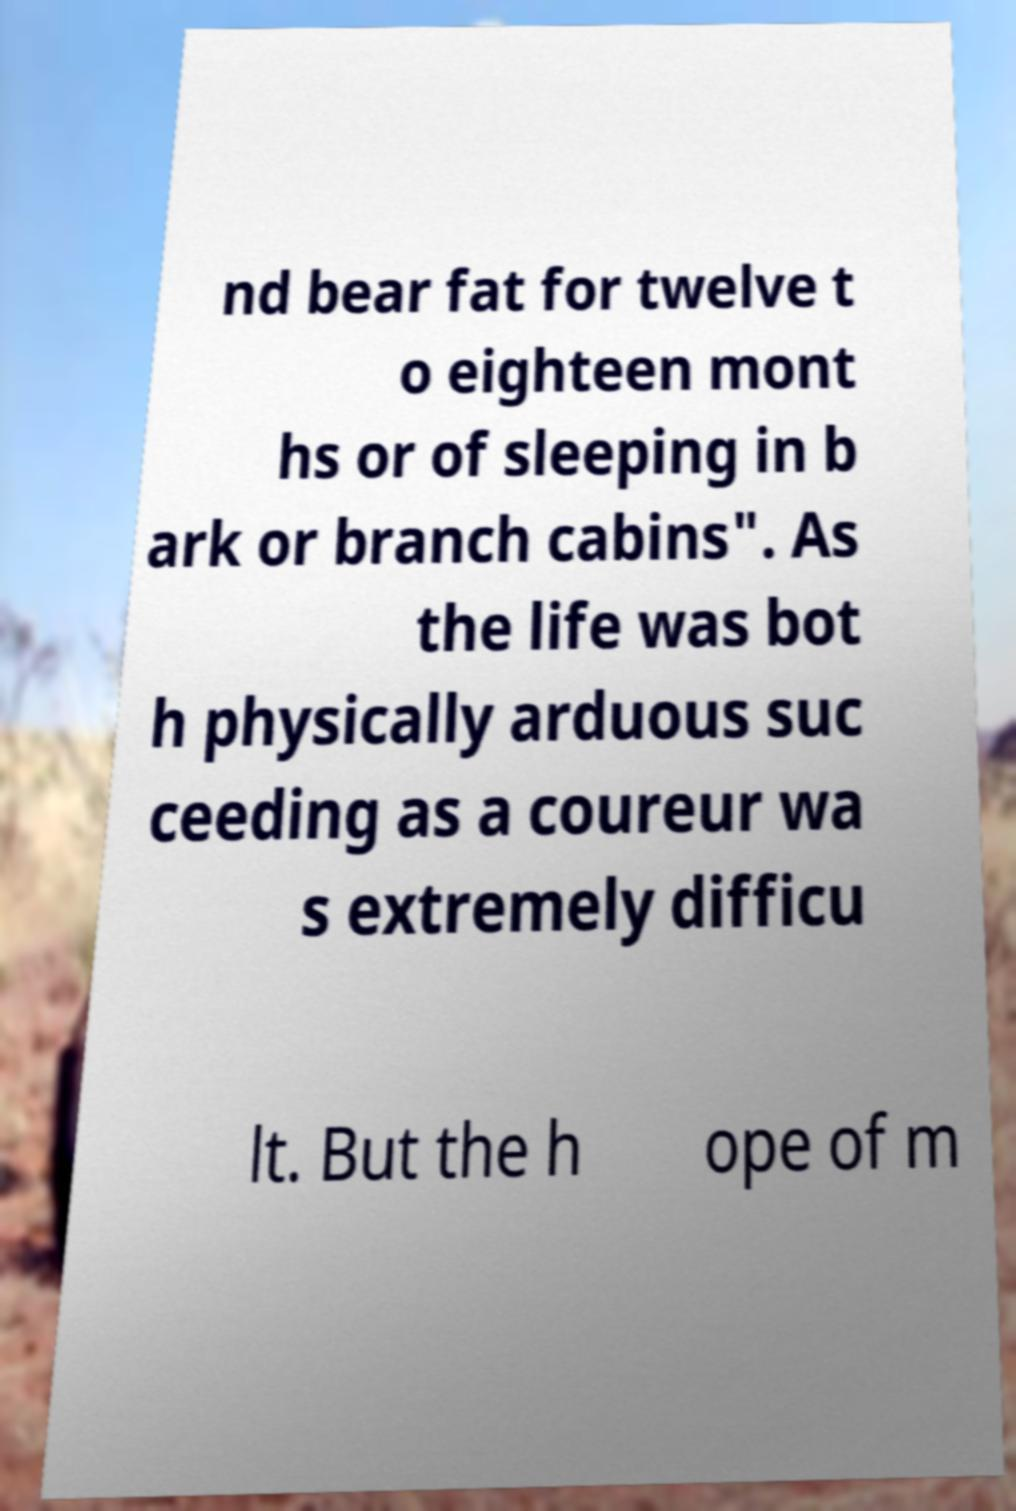What messages or text are displayed in this image? I need them in a readable, typed format. nd bear fat for twelve t o eighteen mont hs or of sleeping in b ark or branch cabins". As the life was bot h physically arduous suc ceeding as a coureur wa s extremely difficu lt. But the h ope of m 